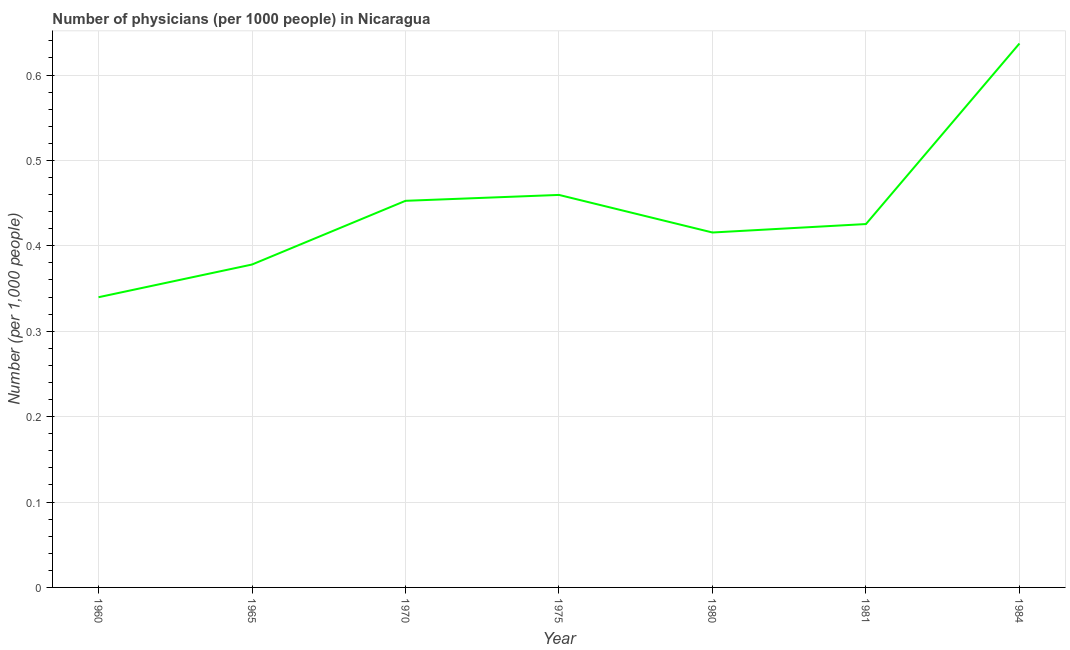What is the number of physicians in 1965?
Your response must be concise. 0.38. Across all years, what is the maximum number of physicians?
Your answer should be very brief. 0.64. Across all years, what is the minimum number of physicians?
Ensure brevity in your answer.  0.34. In which year was the number of physicians maximum?
Your answer should be compact. 1984. What is the sum of the number of physicians?
Provide a succinct answer. 3.11. What is the difference between the number of physicians in 1975 and 1981?
Make the answer very short. 0.03. What is the average number of physicians per year?
Offer a very short reply. 0.44. What is the median number of physicians?
Your response must be concise. 0.43. What is the ratio of the number of physicians in 1960 to that in 1965?
Ensure brevity in your answer.  0.9. Is the number of physicians in 1975 less than that in 1981?
Offer a terse response. No. Is the difference between the number of physicians in 1975 and 1981 greater than the difference between any two years?
Offer a terse response. No. What is the difference between the highest and the second highest number of physicians?
Offer a very short reply. 0.18. What is the difference between the highest and the lowest number of physicians?
Ensure brevity in your answer.  0.3. Does the number of physicians monotonically increase over the years?
Provide a short and direct response. No. How many lines are there?
Keep it short and to the point. 1. What is the difference between two consecutive major ticks on the Y-axis?
Your response must be concise. 0.1. Does the graph contain grids?
Offer a terse response. Yes. What is the title of the graph?
Your answer should be compact. Number of physicians (per 1000 people) in Nicaragua. What is the label or title of the X-axis?
Provide a succinct answer. Year. What is the label or title of the Y-axis?
Make the answer very short. Number (per 1,0 people). What is the Number (per 1,000 people) of 1960?
Offer a very short reply. 0.34. What is the Number (per 1,000 people) of 1965?
Your response must be concise. 0.38. What is the Number (per 1,000 people) in 1970?
Your answer should be very brief. 0.45. What is the Number (per 1,000 people) of 1975?
Offer a terse response. 0.46. What is the Number (per 1,000 people) of 1980?
Give a very brief answer. 0.42. What is the Number (per 1,000 people) in 1981?
Your answer should be very brief. 0.43. What is the Number (per 1,000 people) of 1984?
Give a very brief answer. 0.64. What is the difference between the Number (per 1,000 people) in 1960 and 1965?
Keep it short and to the point. -0.04. What is the difference between the Number (per 1,000 people) in 1960 and 1970?
Make the answer very short. -0.11. What is the difference between the Number (per 1,000 people) in 1960 and 1975?
Your answer should be very brief. -0.12. What is the difference between the Number (per 1,000 people) in 1960 and 1980?
Give a very brief answer. -0.08. What is the difference between the Number (per 1,000 people) in 1960 and 1981?
Keep it short and to the point. -0.09. What is the difference between the Number (per 1,000 people) in 1960 and 1984?
Keep it short and to the point. -0.3. What is the difference between the Number (per 1,000 people) in 1965 and 1970?
Ensure brevity in your answer.  -0.07. What is the difference between the Number (per 1,000 people) in 1965 and 1975?
Your response must be concise. -0.08. What is the difference between the Number (per 1,000 people) in 1965 and 1980?
Keep it short and to the point. -0.04. What is the difference between the Number (per 1,000 people) in 1965 and 1981?
Ensure brevity in your answer.  -0.05. What is the difference between the Number (per 1,000 people) in 1965 and 1984?
Keep it short and to the point. -0.26. What is the difference between the Number (per 1,000 people) in 1970 and 1975?
Provide a short and direct response. -0.01. What is the difference between the Number (per 1,000 people) in 1970 and 1980?
Your answer should be compact. 0.04. What is the difference between the Number (per 1,000 people) in 1970 and 1981?
Ensure brevity in your answer.  0.03. What is the difference between the Number (per 1,000 people) in 1970 and 1984?
Provide a short and direct response. -0.18. What is the difference between the Number (per 1,000 people) in 1975 and 1980?
Provide a short and direct response. 0.04. What is the difference between the Number (per 1,000 people) in 1975 and 1981?
Provide a succinct answer. 0.03. What is the difference between the Number (per 1,000 people) in 1975 and 1984?
Give a very brief answer. -0.18. What is the difference between the Number (per 1,000 people) in 1980 and 1981?
Your answer should be very brief. -0.01. What is the difference between the Number (per 1,000 people) in 1980 and 1984?
Your answer should be very brief. -0.22. What is the difference between the Number (per 1,000 people) in 1981 and 1984?
Offer a terse response. -0.21. What is the ratio of the Number (per 1,000 people) in 1960 to that in 1965?
Your answer should be compact. 0.9. What is the ratio of the Number (per 1,000 people) in 1960 to that in 1970?
Offer a terse response. 0.75. What is the ratio of the Number (per 1,000 people) in 1960 to that in 1975?
Your response must be concise. 0.74. What is the ratio of the Number (per 1,000 people) in 1960 to that in 1980?
Give a very brief answer. 0.82. What is the ratio of the Number (per 1,000 people) in 1960 to that in 1981?
Your answer should be very brief. 0.8. What is the ratio of the Number (per 1,000 people) in 1960 to that in 1984?
Provide a short and direct response. 0.53. What is the ratio of the Number (per 1,000 people) in 1965 to that in 1970?
Offer a terse response. 0.83. What is the ratio of the Number (per 1,000 people) in 1965 to that in 1975?
Provide a short and direct response. 0.82. What is the ratio of the Number (per 1,000 people) in 1965 to that in 1980?
Keep it short and to the point. 0.91. What is the ratio of the Number (per 1,000 people) in 1965 to that in 1981?
Your answer should be compact. 0.89. What is the ratio of the Number (per 1,000 people) in 1965 to that in 1984?
Provide a short and direct response. 0.59. What is the ratio of the Number (per 1,000 people) in 1970 to that in 1980?
Keep it short and to the point. 1.09. What is the ratio of the Number (per 1,000 people) in 1970 to that in 1981?
Ensure brevity in your answer.  1.06. What is the ratio of the Number (per 1,000 people) in 1970 to that in 1984?
Your answer should be compact. 0.71. What is the ratio of the Number (per 1,000 people) in 1975 to that in 1980?
Ensure brevity in your answer.  1.11. What is the ratio of the Number (per 1,000 people) in 1975 to that in 1984?
Your answer should be compact. 0.72. What is the ratio of the Number (per 1,000 people) in 1980 to that in 1984?
Provide a short and direct response. 0.65. What is the ratio of the Number (per 1,000 people) in 1981 to that in 1984?
Your answer should be compact. 0.67. 